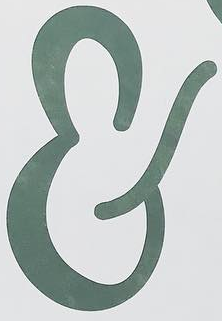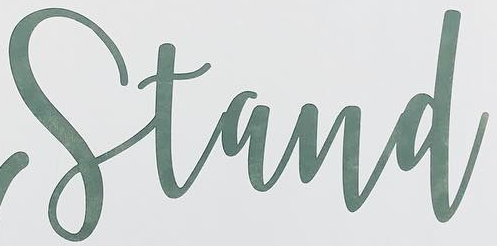Read the text from these images in sequence, separated by a semicolon. &; Stand 